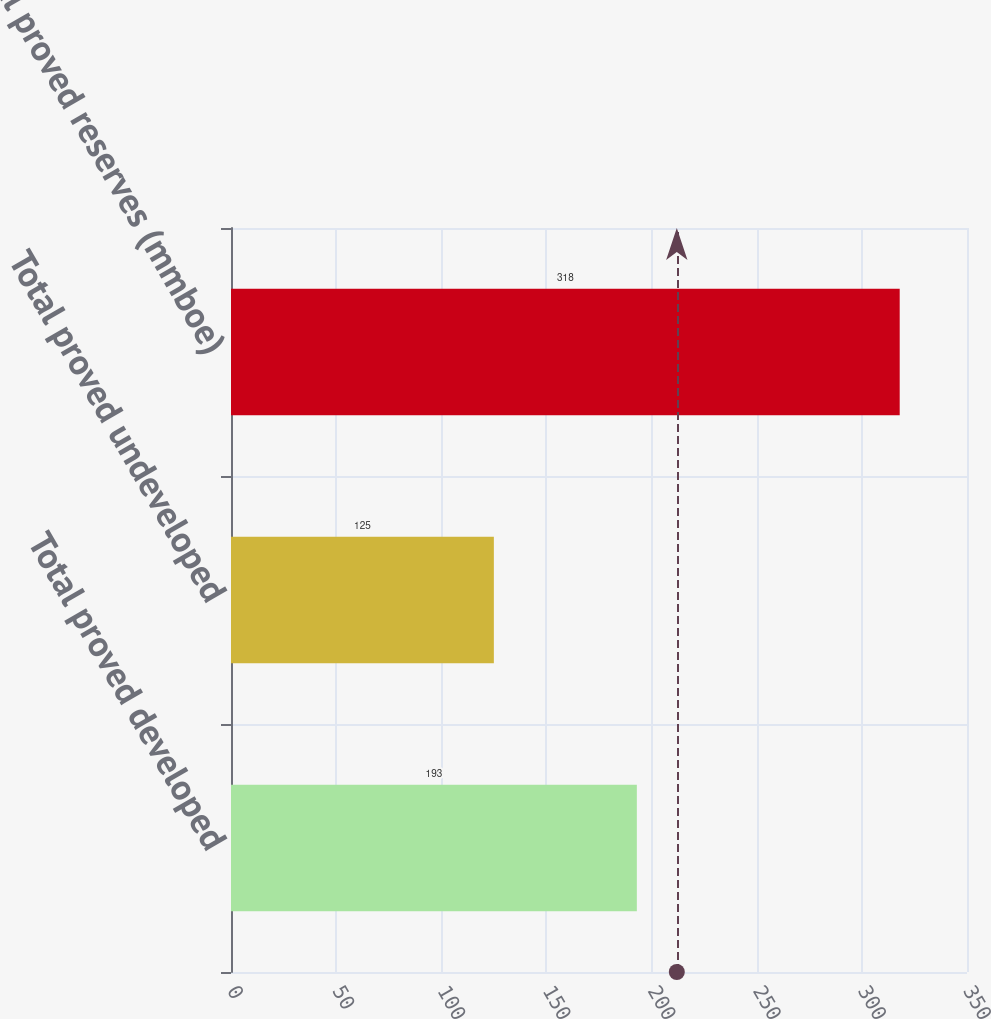Convert chart. <chart><loc_0><loc_0><loc_500><loc_500><bar_chart><fcel>Total proved developed<fcel>Total proved undeveloped<fcel>Total proved reserves (mmboe)<nl><fcel>193<fcel>125<fcel>318<nl></chart> 